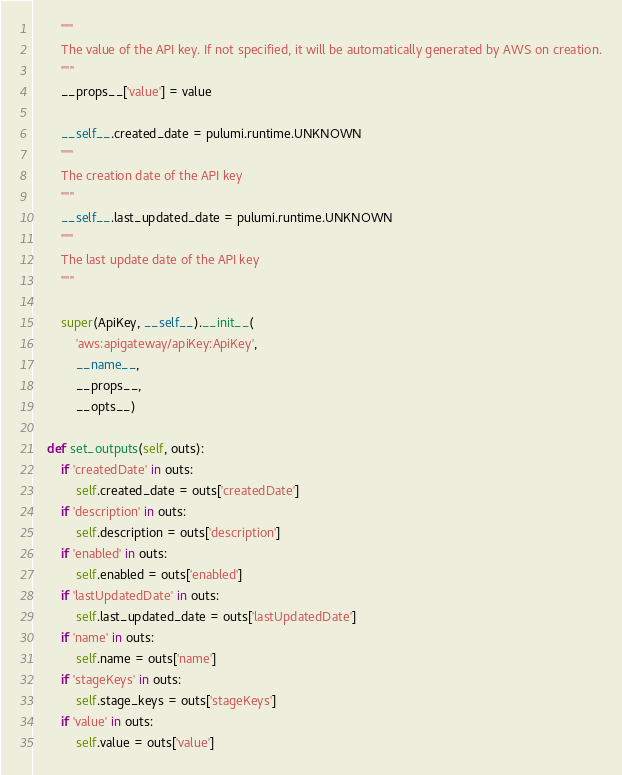<code> <loc_0><loc_0><loc_500><loc_500><_Python_>        """
        The value of the API key. If not specified, it will be automatically generated by AWS on creation.
        """
        __props__['value'] = value

        __self__.created_date = pulumi.runtime.UNKNOWN
        """
        The creation date of the API key
        """
        __self__.last_updated_date = pulumi.runtime.UNKNOWN
        """
        The last update date of the API key
        """

        super(ApiKey, __self__).__init__(
            'aws:apigateway/apiKey:ApiKey',
            __name__,
            __props__,
            __opts__)

    def set_outputs(self, outs):
        if 'createdDate' in outs:
            self.created_date = outs['createdDate']
        if 'description' in outs:
            self.description = outs['description']
        if 'enabled' in outs:
            self.enabled = outs['enabled']
        if 'lastUpdatedDate' in outs:
            self.last_updated_date = outs['lastUpdatedDate']
        if 'name' in outs:
            self.name = outs['name']
        if 'stageKeys' in outs:
            self.stage_keys = outs['stageKeys']
        if 'value' in outs:
            self.value = outs['value']
</code> 